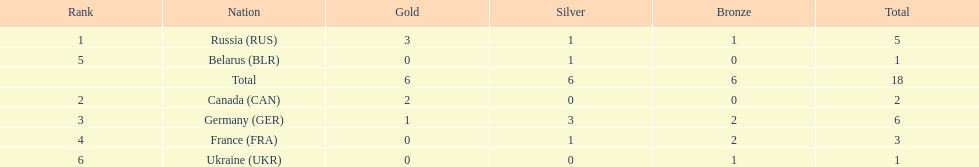Who had a larger total medal count, france or canada? France. 